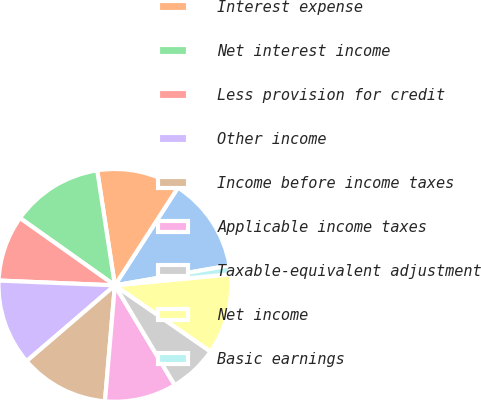Convert chart to OTSL. <chart><loc_0><loc_0><loc_500><loc_500><pie_chart><fcel>Interest income<fcel>Interest expense<fcel>Net interest income<fcel>Less provision for credit<fcel>Other income<fcel>Income before income taxes<fcel>Applicable income taxes<fcel>Taxable-equivalent adjustment<fcel>Net income<fcel>Basic earnings<nl><fcel>13.15%<fcel>11.55%<fcel>12.75%<fcel>9.16%<fcel>11.95%<fcel>12.35%<fcel>9.96%<fcel>6.77%<fcel>11.16%<fcel>1.2%<nl></chart> 